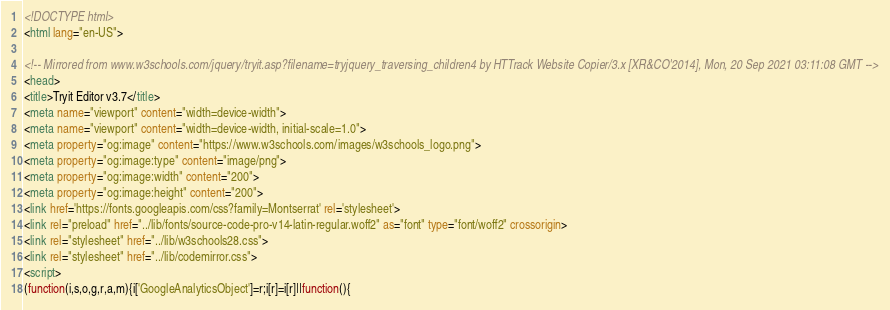Convert code to text. <code><loc_0><loc_0><loc_500><loc_500><_HTML_>
<!DOCTYPE html>
<html lang="en-US">

<!-- Mirrored from www.w3schools.com/jquery/tryit.asp?filename=tryjquery_traversing_children4 by HTTrack Website Copier/3.x [XR&CO'2014], Mon, 20 Sep 2021 03:11:08 GMT -->
<head>
<title>Tryit Editor v3.7</title>
<meta name="viewport" content="width=device-width">
<meta name="viewport" content="width=device-width, initial-scale=1.0">
<meta property="og:image" content="https://www.w3schools.com/images/w3schools_logo.png">
<meta property="og:image:type" content="image/png">
<meta property="og:image:width" content="200">
<meta property="og:image:height" content="200">
<link href='https://fonts.googleapis.com/css?family=Montserrat' rel='stylesheet'>
<link rel="preload" href="../lib/fonts/source-code-pro-v14-latin-regular.woff2" as="font" type="font/woff2" crossorigin>
<link rel="stylesheet" href="../lib/w3schools28.css">
<link rel="stylesheet" href="../lib/codemirror.css">
<script>
(function(i,s,o,g,r,a,m){i['GoogleAnalyticsObject']=r;i[r]=i[r]||function(){</code> 